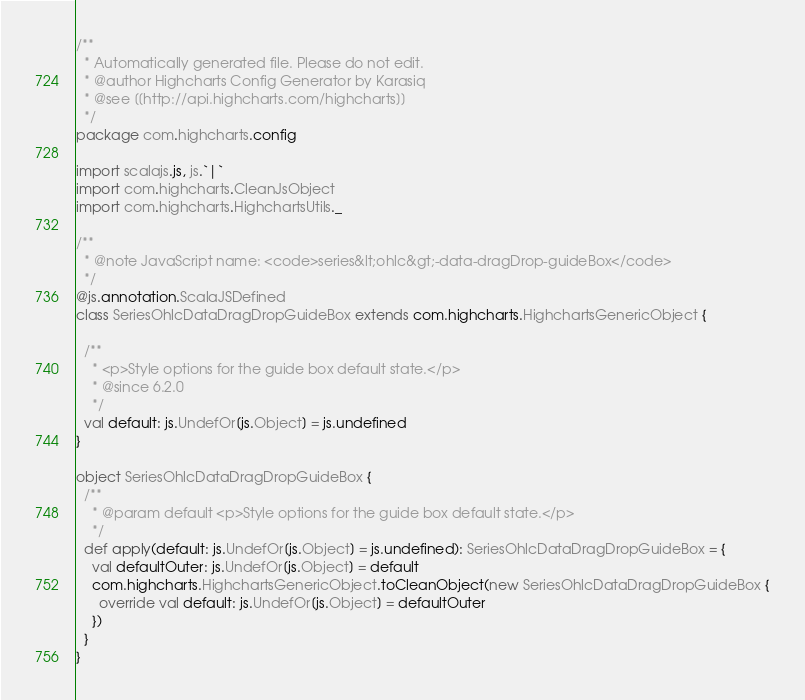Convert code to text. <code><loc_0><loc_0><loc_500><loc_500><_Scala_>/**
  * Automatically generated file. Please do not edit.
  * @author Highcharts Config Generator by Karasiq
  * @see [[http://api.highcharts.com/highcharts]]
  */
package com.highcharts.config

import scalajs.js, js.`|`
import com.highcharts.CleanJsObject
import com.highcharts.HighchartsUtils._

/**
  * @note JavaScript name: <code>series&lt;ohlc&gt;-data-dragDrop-guideBox</code>
  */
@js.annotation.ScalaJSDefined
class SeriesOhlcDataDragDropGuideBox extends com.highcharts.HighchartsGenericObject {

  /**
    * <p>Style options for the guide box default state.</p>
    * @since 6.2.0
    */
  val default: js.UndefOr[js.Object] = js.undefined
}

object SeriesOhlcDataDragDropGuideBox {
  /**
    * @param default <p>Style options for the guide box default state.</p>
    */
  def apply(default: js.UndefOr[js.Object] = js.undefined): SeriesOhlcDataDragDropGuideBox = {
    val defaultOuter: js.UndefOr[js.Object] = default
    com.highcharts.HighchartsGenericObject.toCleanObject(new SeriesOhlcDataDragDropGuideBox {
      override val default: js.UndefOr[js.Object] = defaultOuter
    })
  }
}
</code> 